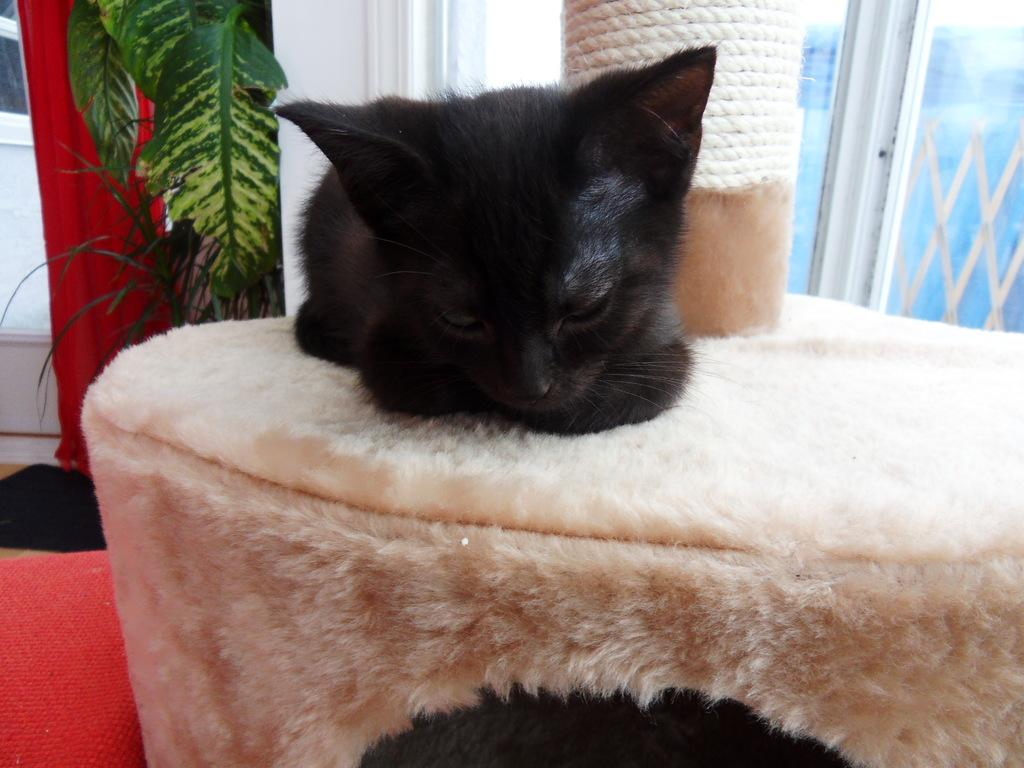What animal is located in the middle of the image? There is a cat in the middle of the image. What type of vegetation is on the left side of the image? There are plants on the left side of the image. What feature can be seen on the right side of the image? There appears to be a glass window on the right side of the image. Where is the birth of the new baby taking place in the image? There is no mention of a baby or a birth in the image; it features a cat, plants, and a glass window. What type of stem is visible in the image? There is no stem visible in the image. 